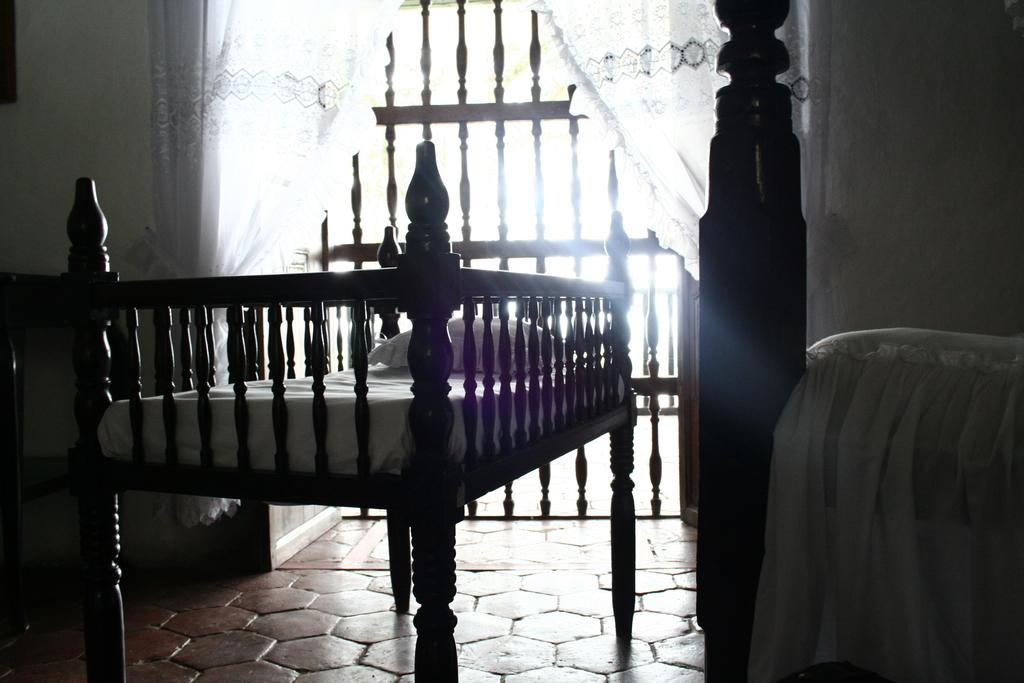What is placed on the floor in the image? There is a bed on the floor in the image. What is on top of the bed? There is a pillow on the bed. What can be seen in the background of the image? There is a grille, doors, and curtains in the background of the image. What is located on the right side of the image? There is a pillar and a cloth on the right side of the image. What type of pencil can be seen on the bed in the image? There is no pencil present on the bed or anywhere else in the image. 